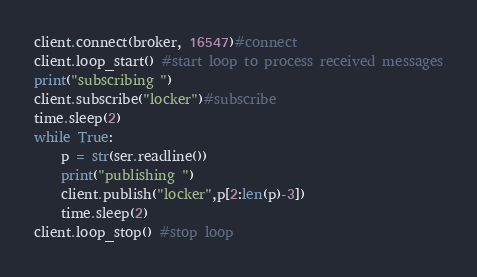<code> <loc_0><loc_0><loc_500><loc_500><_Python_>client.connect(broker, 16547)#connect
client.loop_start() #start loop to process received messages
print("subscribing ")
client.subscribe("locker")#subscribe
time.sleep(2)
while True:
	p = str(ser.readline())
	print("publishing ")
	client.publish("locker",p[2:len(p)-3])
	time.sleep(2)
client.loop_stop() #stop loop</code> 